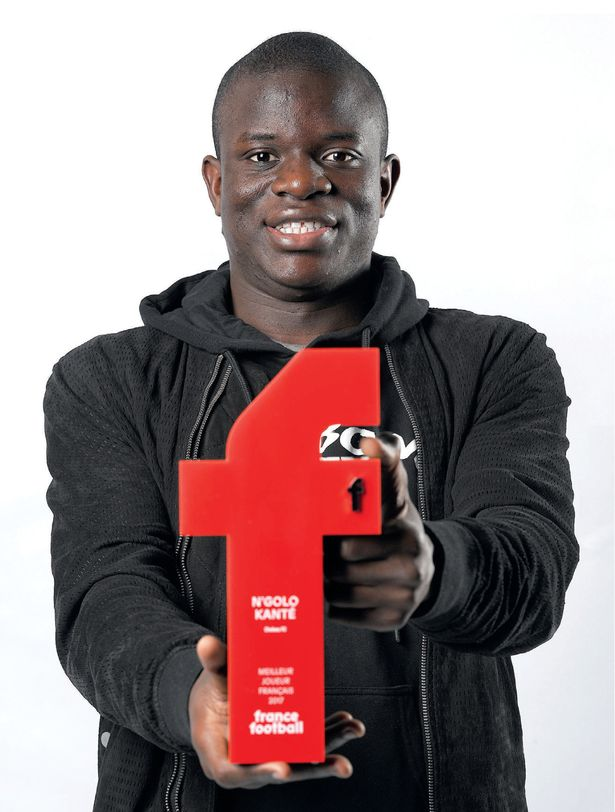Based on the details provided by the award, what can be inferred about the individual's achievements in the sport of soccer, and what might be the significance of the award in the context of their career? Based on the award's details, it can be inferred that the individual has been recognized as the 'Player of the Year' by France Football, which is a prestigious honor in the sport of soccer. This accolade suggests that the individual has exhibited extraordinary performance, exemplary skill, and possibly leadership on the field. The award's significance in the context of their career is substantial, serving as a testament to their prowess and contributions to the sport. It potentially elevates their standing among peers and fans, marking a pinnacle in their professional journey and likely leading to further recognition and opportunities within the sport. 